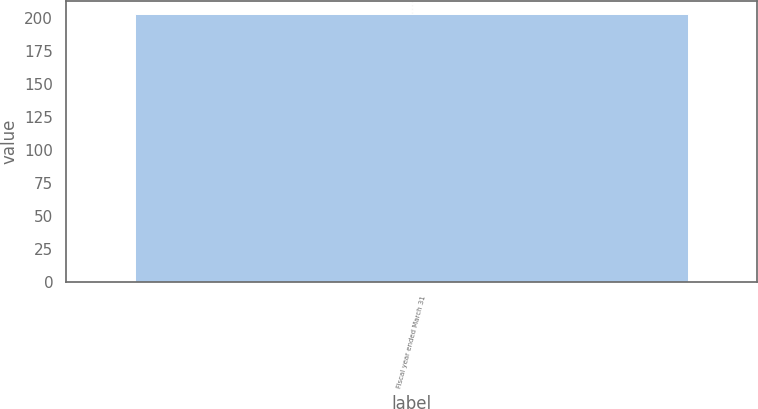Convert chart. <chart><loc_0><loc_0><loc_500><loc_500><bar_chart><fcel>Fiscal year ended March 31<nl><fcel>203<nl></chart> 